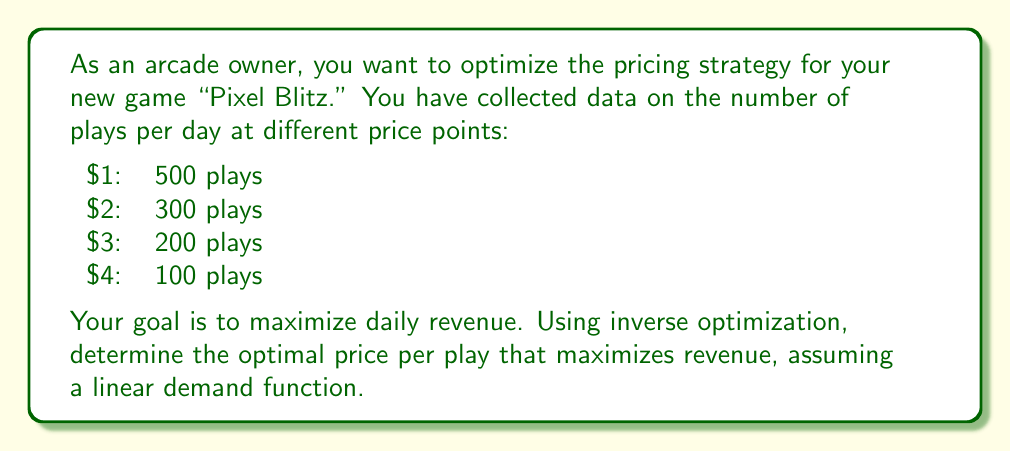Show me your answer to this math problem. Let's approach this step-by-step:

1) First, we need to establish the linear demand function. Let $p$ be the price and $q$ be the quantity (number of plays). We can use the given data points to find the slope and y-intercept of the line.

2) Using the points (1, 500) and (4, 100), we can calculate the slope:
   
   $$m = \frac{100 - 500}{4 - 1} = -\frac{400}{3} = -133.33$$

3) Now we can use the point-slope form to find the y-intercept:
   
   $$q - 500 = -133.33(p - 1)$$
   $$q = -133.33p + 633.33$$

4) Our demand function is thus:
   
   $$q = 633.33 - 133.33p$$

5) The revenue function R is price times quantity:
   
   $$R = pq = p(633.33 - 133.33p) = 633.33p - 133.33p^2$$

6) To find the maximum revenue, we differentiate R with respect to p and set it to zero:
   
   $$\frac{dR}{dp} = 633.33 - 266.66p = 0$$

7) Solving this equation:
   
   $$266.66p = 633.33$$
   $$p = 2.375$$

8) The second derivative is negative (-266.66), confirming this is a maximum.

9) Therefore, the optimal price is $2.38 (rounded to the nearest cent).

10) We can verify the revenue at this price:
    
    $$R = 2.38(633.33 - 133.33(2.38)) = 2.38(316.67) = 753.67$$

This is indeed higher than the revenue at the given price points.
Answer: $2.38 per play 